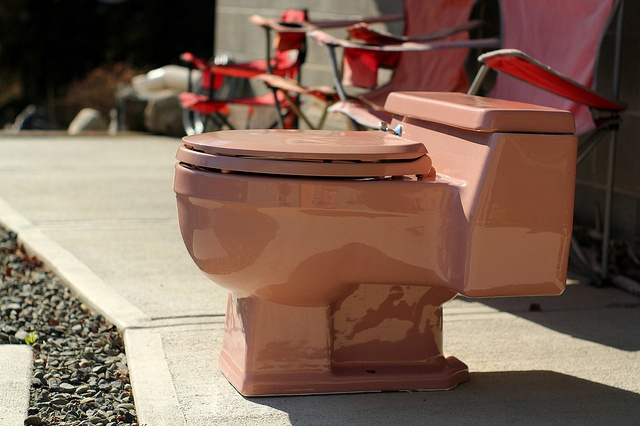Describe the objects in this image and their specific colors. I can see toilet in black, brown, and maroon tones, chair in black, maroon, tan, and darkgray tones, chair in black, brown, and maroon tones, and chair in black, gray, maroon, and brown tones in this image. 